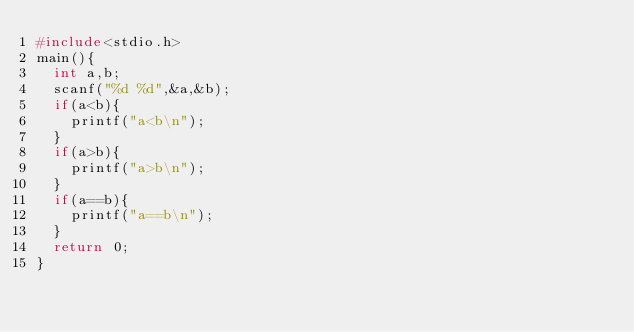<code> <loc_0><loc_0><loc_500><loc_500><_C_>#include<stdio.h>
main(){
  int a,b;
  scanf("%d %d",&a,&b);
  if(a<b){
    printf("a<b\n");
  }
  if(a>b){
    printf("a>b\n");
  }
  if(a==b){
    printf("a==b\n");
  }
  return 0;
}</code> 